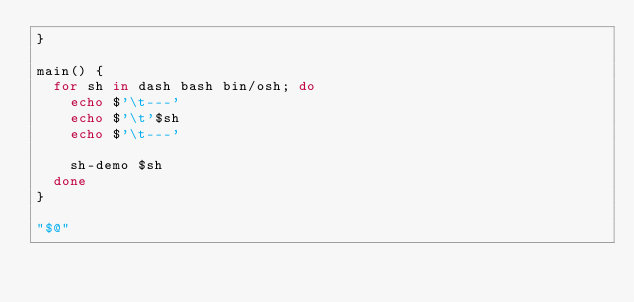Convert code to text. <code><loc_0><loc_0><loc_500><loc_500><_Bash_>}

main() {
  for sh in dash bash bin/osh; do
    echo $'\t---'
    echo $'\t'$sh
    echo $'\t---'

    sh-demo $sh
  done
}

"$@"
</code> 